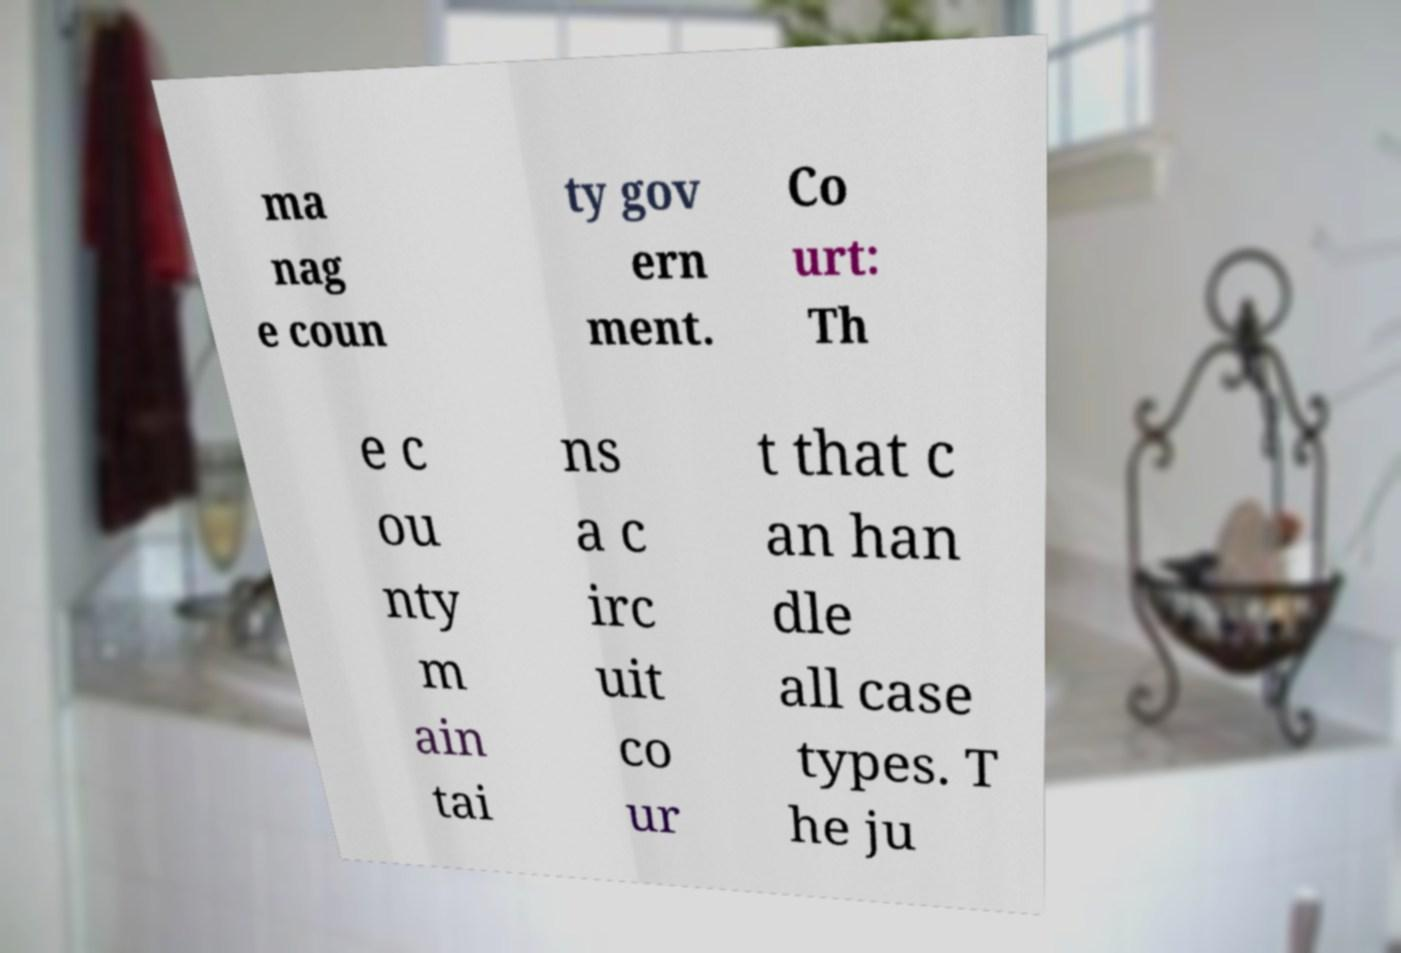Can you read and provide the text displayed in the image?This photo seems to have some interesting text. Can you extract and type it out for me? ma nag e coun ty gov ern ment. Co urt: Th e c ou nty m ain tai ns a c irc uit co ur t that c an han dle all case types. T he ju 